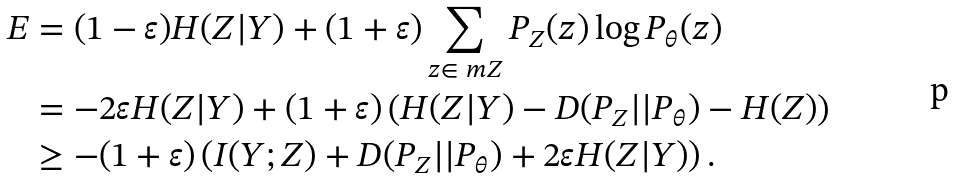Convert formula to latex. <formula><loc_0><loc_0><loc_500><loc_500>E & = ( 1 - \varepsilon ) H ( Z | Y ) + ( 1 + \varepsilon ) \sum _ { z \in \ m { Z } } P _ { Z } ( z ) \log P _ { \theta } ( z ) \\ & = - 2 \varepsilon H ( Z | Y ) + ( 1 + \varepsilon ) \left ( H ( Z | Y ) - D ( P _ { Z } | | P _ { \theta } ) - H ( Z ) \right ) \\ & \geq - ( 1 + \varepsilon ) \left ( I ( Y ; Z ) + D ( P _ { Z } | | P _ { \theta } ) + 2 \varepsilon H ( Z | Y ) \right ) .</formula> 